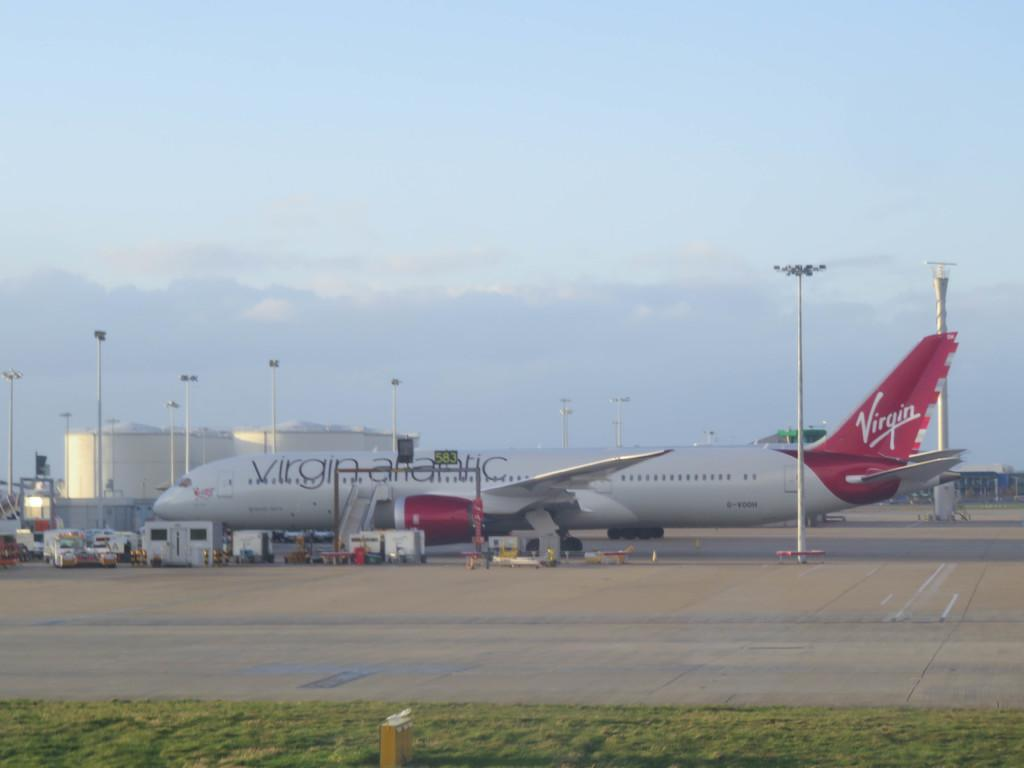<image>
Render a clear and concise summary of the photo. A large Virgin Atlantic passenger jet is sitting at an airport. 